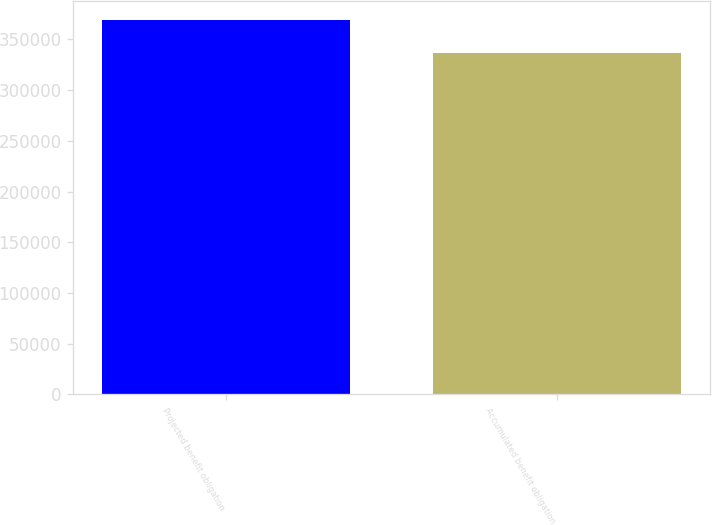<chart> <loc_0><loc_0><loc_500><loc_500><bar_chart><fcel>Projected benefit obligation<fcel>Accumulated benefit obligation<nl><fcel>369289<fcel>336095<nl></chart> 